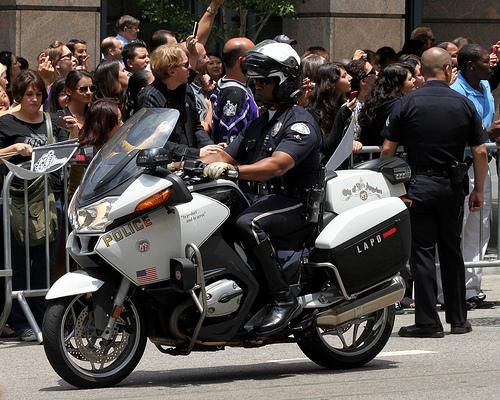Write a sentence that describes the key components and action seen in the image. A uniformed police officer wearing a helmet skillfully maneuvers his white LAPD motorcycle as an attentive crowd observes from behind fencing. Capture the essence of the image in the form of a headline. "Officer Patrols on White LAPD Motorcycle as the Crowd Looks On" Summarize the main elements in the photo using a combination of keywords. Police officer, white LAPD motorcycle, American flag, crowd, fence, sunglasses, helmet Describe the scene from the perspective of the policeman. As a police officer, I confidently ride my white LAPD motorcycle, with the crowd observing from behind the fence. Write a simple and short description of the image. A policeman on a white LAPD motorcycle, and a crowd of people behind a fence. Create a descriptive, attention-grabbing title for the image. "Policeman on Motorcycle Catches the Eye of an Eager Crowd" Provide a vivid yet concise description of what you see in the image. In a lively scene, a helmeted policeman skillfully navigates his white LAPD motorcycle as onlookers gather behind a fence. Using a narrative style, describe what the picture depicts. A story unfolds with a police officer on his motorcycle, patrolling an area where a crowd of people gather behind a fence, watching. Imagine you are describing the image for someone who cannot see it. What are the main elements you would describe? The image features a police officer riding a white LAPD motorcycle with an American flag, while a diverse crowd of people watch from behind a fence. Mention the primary focus of the image while describing the action taking place. A police officer is riding a white LAPD motorcycle with an American flag on display. 